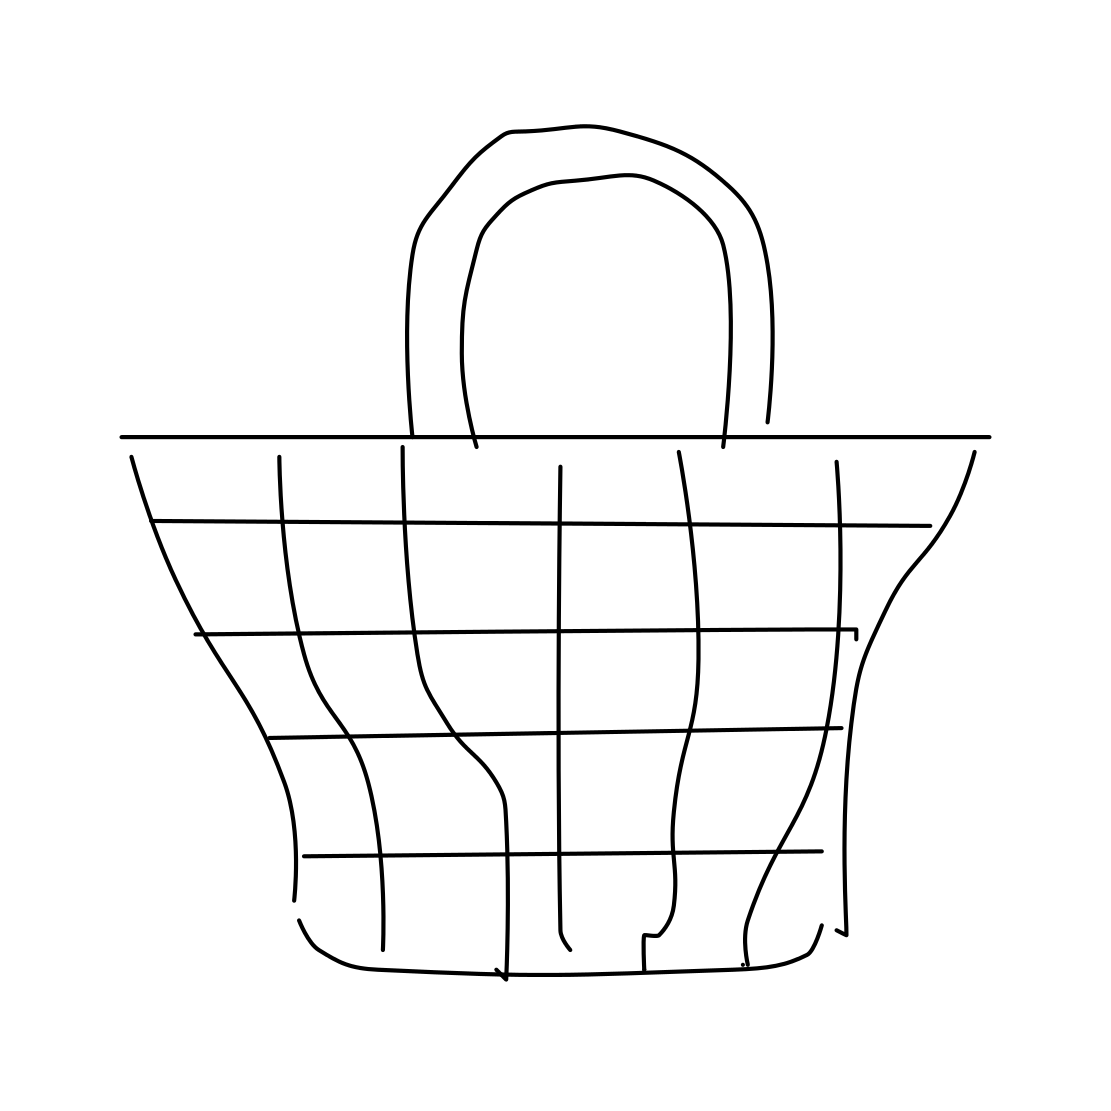Is the grid pattern functional or purely decorative? The grid pattern in the drawing can be interpreted both ways. Functionally, a grid can add structural integrity and help contain items. Decoratively, it adds a visually interesting element that breaks the simplicity of the design and gives it a modern look. 